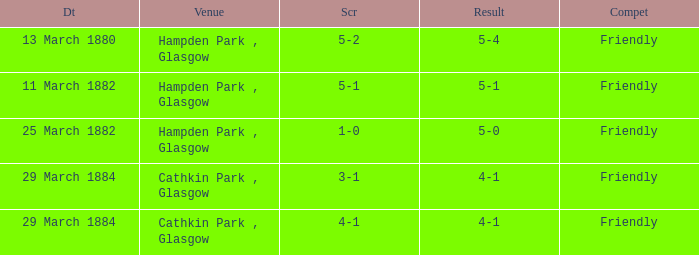What event ended with a 4-1 score, where the final result was 4-1? Friendly. 